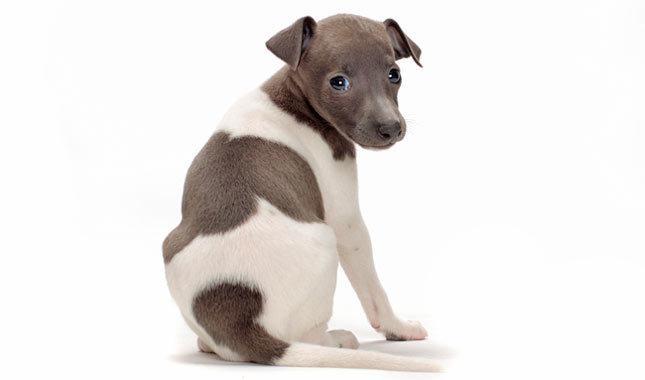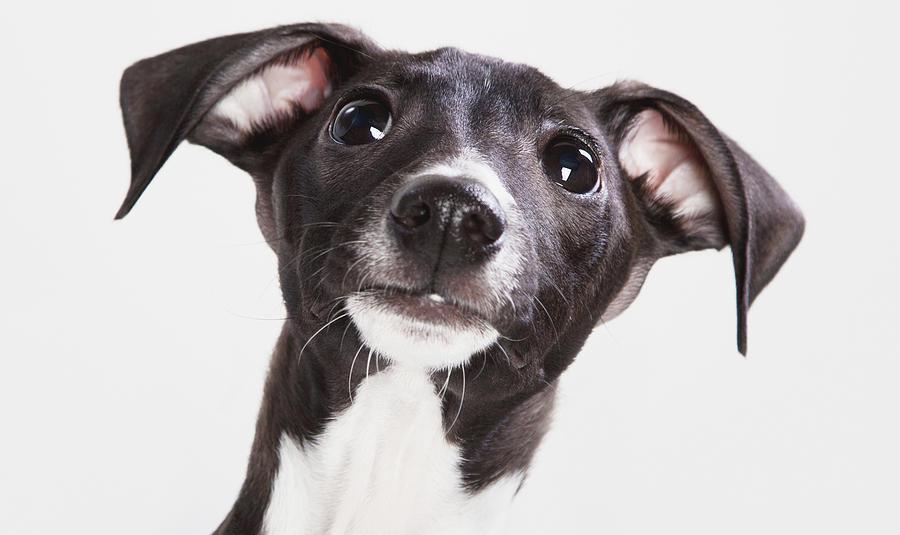The first image is the image on the left, the second image is the image on the right. For the images shown, is this caption "An image shows a hound wearing a collar and sitting upright." true? Answer yes or no. No. The first image is the image on the left, the second image is the image on the right. For the images displayed, is the sentence "At least one dog is wearing a collar." factually correct? Answer yes or no. No. 